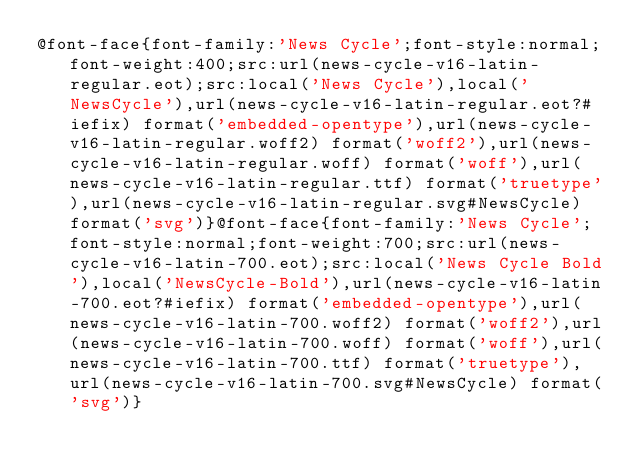Convert code to text. <code><loc_0><loc_0><loc_500><loc_500><_CSS_>@font-face{font-family:'News Cycle';font-style:normal;font-weight:400;src:url(news-cycle-v16-latin-regular.eot);src:local('News Cycle'),local('NewsCycle'),url(news-cycle-v16-latin-regular.eot?#iefix) format('embedded-opentype'),url(news-cycle-v16-latin-regular.woff2) format('woff2'),url(news-cycle-v16-latin-regular.woff) format('woff'),url(news-cycle-v16-latin-regular.ttf) format('truetype'),url(news-cycle-v16-latin-regular.svg#NewsCycle) format('svg')}@font-face{font-family:'News Cycle';font-style:normal;font-weight:700;src:url(news-cycle-v16-latin-700.eot);src:local('News Cycle Bold'),local('NewsCycle-Bold'),url(news-cycle-v16-latin-700.eot?#iefix) format('embedded-opentype'),url(news-cycle-v16-latin-700.woff2) format('woff2'),url(news-cycle-v16-latin-700.woff) format('woff'),url(news-cycle-v16-latin-700.ttf) format('truetype'),url(news-cycle-v16-latin-700.svg#NewsCycle) format('svg')}</code> 